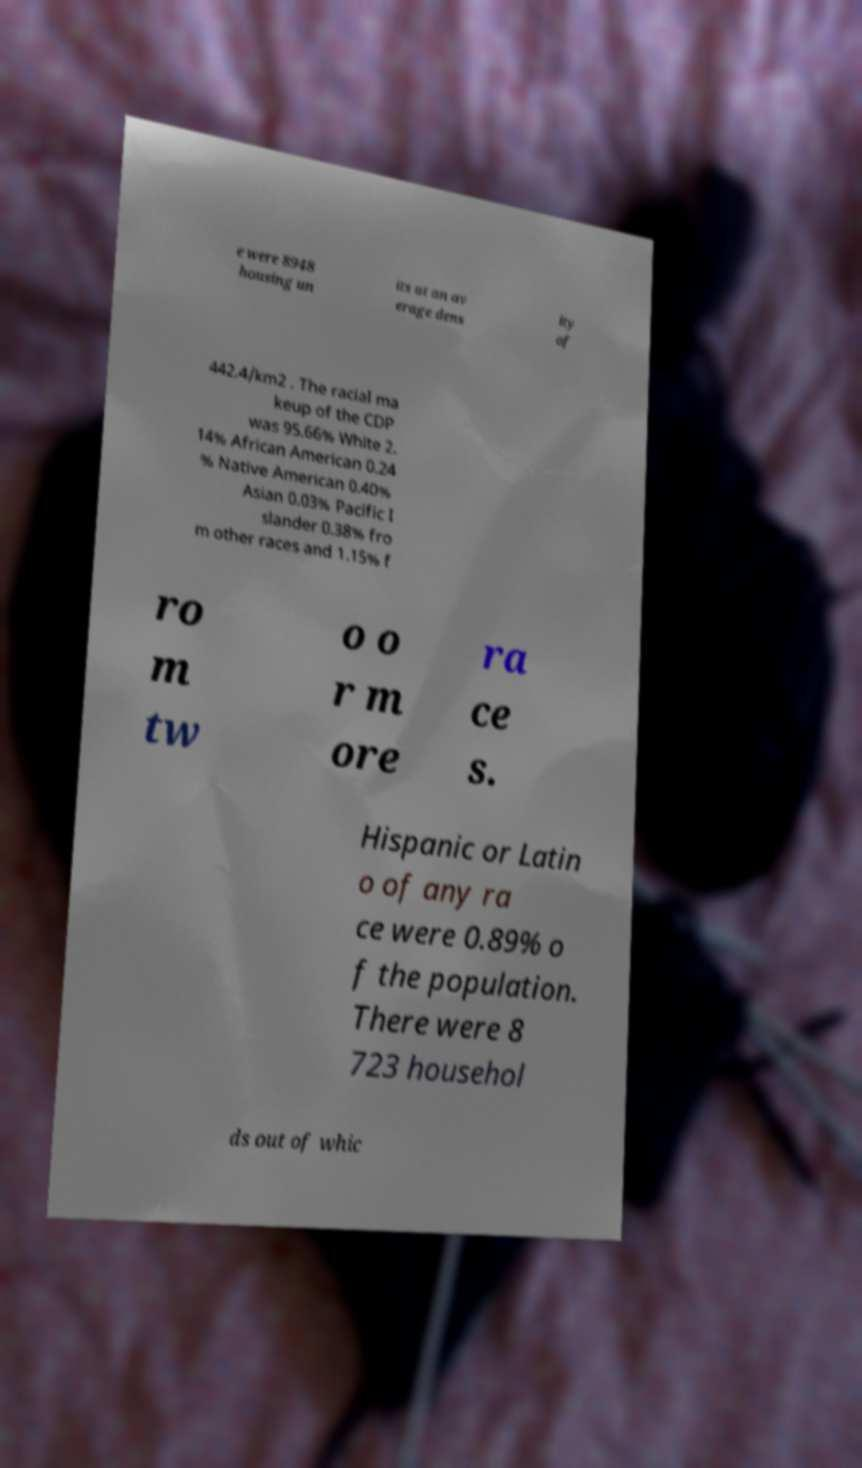Could you assist in decoding the text presented in this image and type it out clearly? e were 8948 housing un its at an av erage dens ity of 442.4/km2 . The racial ma keup of the CDP was 95.66% White 2. 14% African American 0.24 % Native American 0.40% Asian 0.03% Pacific I slander 0.38% fro m other races and 1.15% f ro m tw o o r m ore ra ce s. Hispanic or Latin o of any ra ce were 0.89% o f the population. There were 8 723 househol ds out of whic 